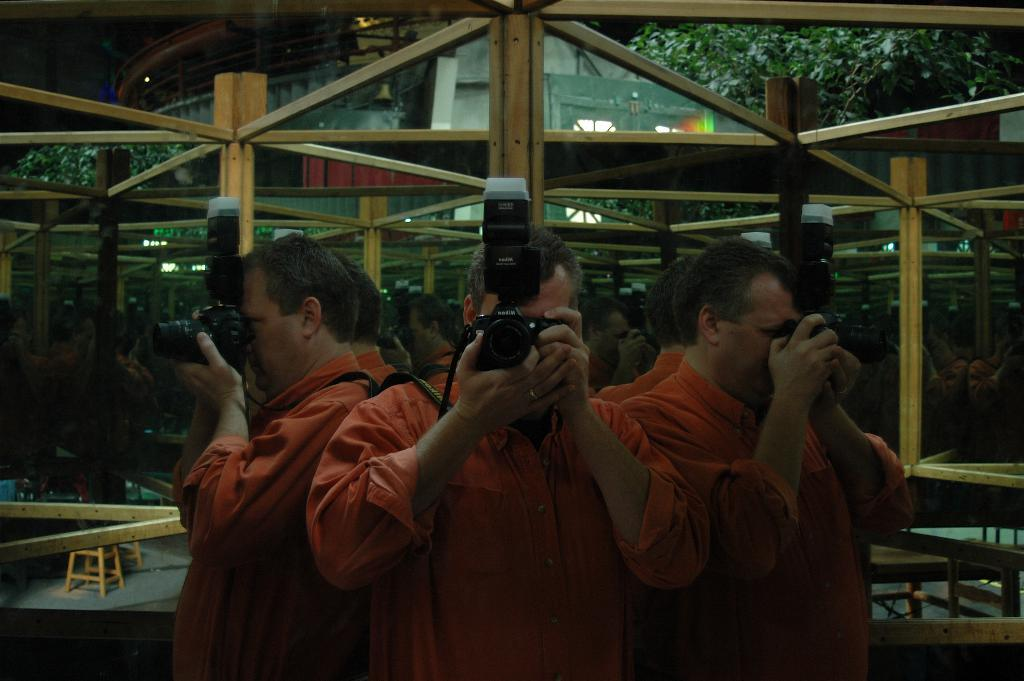What is the person in the image doing? The person is taking a photo. What color is the shirt the person is wearing? The person is wearing an orange shirt. What objects are surrounding the person? There are mirrors surrounding the person. What can be seen in the background behind the person? There are trees visible behind the person. What type of jar is sitting on the dinner table in the image? There is no jar or dinner table present in the image. How many houses can be seen in the background of the image? There are no houses visible in the background of the image; only trees can be seen. 